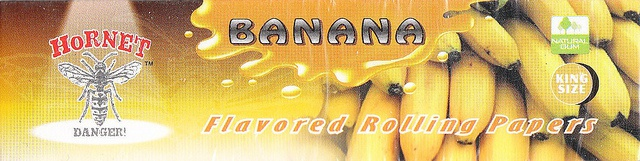Describe the objects in this image and their specific colors. I can see banana in darkgray, khaki, and tan tones, banana in darkgray, gold, orange, tan, and gray tones, banana in darkgray, gold, orange, khaki, and ivory tones, banana in darkgray, khaki, tan, and ivory tones, and banana in darkgray, gold, orange, khaki, and gray tones in this image. 